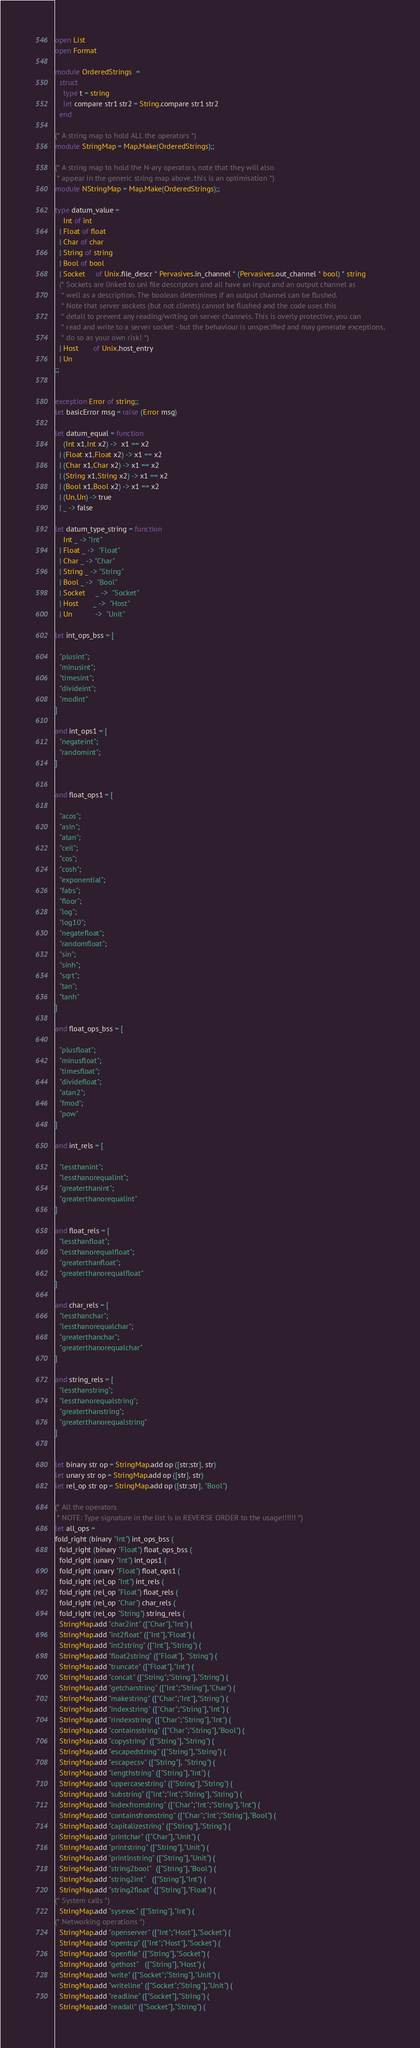<code> <loc_0><loc_0><loc_500><loc_500><_OCaml_>open List
open Format

module OrderedStrings  = 
  struct 
    type t = string
    let compare str1 str2 = String.compare str1 str2 
  end

(* A string map to hold ALL the operators *)
module StringMap = Map.Make(OrderedStrings);;

(* A string map to hold the N-ary operators, note that they will also
 * appear in the generic string map above, this is an optimisation *)
module NStringMap = Map.Make(OrderedStrings);;

type datum_value =
    Int of int
  | Float of float
  | Char of char
  | String of string
  | Bool of bool 
  | Socket     of Unix.file_descr * Pervasives.in_channel * (Pervasives.out_channel * bool) * string 
  (* Sockets are linked to uni file descriptors and all have an input and an output channel as
   * well as a description. The boolean determines if an output channel can be flushed.
   * Note that server sockets (but not clients) cannot be flushed and the code uses this
   * detail to prevent any reading/writing on server channels. This is overly protective, you can
   * read and write to a server socket - but the behaviour is unspecified and may generate exceptions,
   * do so as your own risk! *)
  | Host       of Unix.host_entry
  | Un
;;


exception Error of string;;
let basicError msg = raise (Error msg)

let datum_equal = function
    (Int x1,Int x2) ->  x1 == x2 
  | (Float x1,Float x2) -> x1 == x2 
  | (Char x1,Char x2) -> x1 == x2 
  | (String x1,String x2) -> x1 == x2 
  | (Bool x1,Bool x2) -> x1 == x2
  | (Un,Un) -> true
  | _ -> false 

let datum_type_string = function
    Int _ -> "Int" 
  | Float _ ->  "Float" 
  | Char _ -> "Char"
  | String _ -> "String" 
  | Bool _ ->  "Bool"
  | Socket     _ ->  "Socket"
  | Host       _ ->  "Host"
  | Un           ->  "Unit"         

let int_ops_bss = [
  
  "plusint";
  "minusint";
  "timesint";
  "divideint";
  "modint"
] 

and int_ops1 = [
  "negateint";
  "randomint";
]


and float_ops1 = [

  "acos";
  "asin";
  "atan";
  "ceil";
  "cos";
  "cosh";
  "exponential";
  "fabs";
  "floor";
  "log";
  "log10";
  "negatefloat";
  "randomfloat";
  "sin";
  "sinh";
  "sqrt";
  "tan";
  "tanh"
] 

and float_ops_bss = [ 

  "plusfloat";
  "minusfloat";
  "timesfloat";
  "dividefloat";
  "atan2";
  "fmod";
  "pow"
]

and int_rels = [ 

  "lessthanint";
  "lessthanorequalint";
  "greaterthanint";
  "greaterthanorequalint"
] 

and float_rels = [ 
  "lessthanfloat";
  "lessthanorequalfloat";
  "greaterthanfloat";
  "greaterthanorequalfloat"
] 

and char_rels = [ 
  "lessthanchar";
  "lessthanorequalchar";
  "greaterthanchar";
  "greaterthanorequalchar"
] 

and string_rels = [ 
  "lessthanstring";
  "lessthanorequalstring";
  "greaterthanstring";
  "greaterthanorequalstring"
] 


let binary str op = StringMap.add op ([str;str], str) 
let unary str op = StringMap.add op ([str], str) 
let rel_op str op = StringMap.add op ([str;str], "Bool") 

(* All the operators 
 * NOTE: Type signature in the list is in REVERSE ORDER to the usage!!!!!! *)
let all_ops =
fold_right (binary "Int") int_ops_bss (
  fold_right (binary "Float") float_ops_bss (
  fold_right (unary "Int") int_ops1 (
  fold_right (unary "Float") float_ops1 (
  fold_right (rel_op "Int") int_rels (
  fold_right (rel_op "Float") float_rels (
  fold_right (rel_op "Char") char_rels (
  fold_right (rel_op "String") string_rels (
  StringMap.add "char2int" (["Char"],"Int") (
  StringMap.add "int2float" (["Int"],"Float") (
  StringMap.add "int2string" (["Int"],"String") (
  StringMap.add "float2string" (["Float"], "String") (
  StringMap.add "truncate" (["Float"],"Int") (
  StringMap.add "concat" (["String";"String"],"String") (
  StringMap.add "getcharstring" (["Int";"String"],"Char") (
  StringMap.add "makestring" (["Char";"Int"],"String") (
  StringMap.add "indexstring" (["Char";"String"],"Int") (
  StringMap.add "rindexstring" (["Char";"String"],"Int") (
  StringMap.add "containsstring" (["Char";"String"],"Bool") (
  StringMap.add "copystring" (["String"],"String") (
  StringMap.add "escapedstring" (["String"],"String") (
  StringMap.add "escapecsv" (["String"], "String") (
  StringMap.add "lengthstring" (["String"],"Int") (
  StringMap.add "uppercasestring" (["String"],"String") (
  StringMap.add "substring" (["Int";"Int";"String"],"String") (
  StringMap.add "indexfromstring" (["Char";"Int";"String"],"Int") (
  StringMap.add "containsfromstring" (["Char";"Int";"String"],"Bool") (
  StringMap.add "capitalizestring" (["String"],"String") (
  StringMap.add "printchar" (["Char"],"Unit") ( 
  StringMap.add "printstring" (["String"],"Unit") ( 
  StringMap.add "printlnstring" (["String"],"Unit") (
  StringMap.add "string2bool"  (["String"],"Bool") (
  StringMap.add "string2int"   (["String"],"Int") (
  StringMap.add "string2float" (["String"],"Float") (
(* System calls *)
  StringMap.add "sysexec" (["String"],"Int") (
(* Networking operations *)
  StringMap.add "openserver" (["Int";"Host"],"Socket") (
  StringMap.add "opentcp" (["Int";"Host"],"Socket") (
  StringMap.add "openfile" (["String"],"Socket") (
  StringMap.add "gethost"   (["String"],"Host") (
  StringMap.add "write" (["Socket";"String"],"Unit") (
  StringMap.add "writeline" (["Socket";"String"],"Unit") (
  StringMap.add "readline" (["Socket"],"String") (
  StringMap.add "readall" (["Socket"],"String") (</code> 